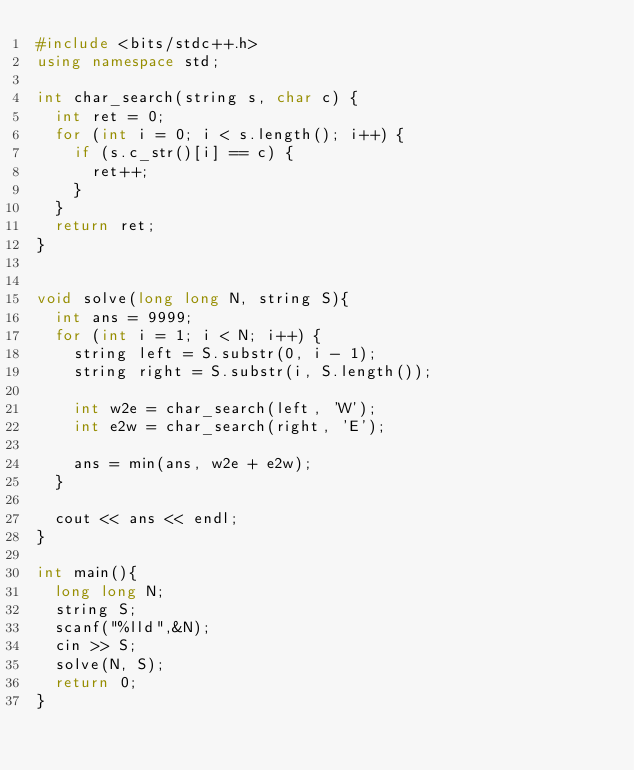<code> <loc_0><loc_0><loc_500><loc_500><_C++_>#include <bits/stdc++.h>
using namespace std;

int char_search(string s, char c) {
	int ret = 0;
	for (int i = 0; i < s.length(); i++) {
		if (s.c_str()[i] == c) {
			ret++;
		} 
	}
	return ret;
}


void solve(long long N, string S){
	int ans = 9999;
	for (int i = 1; i < N; i++) {
		string left = S.substr(0, i - 1);
		string right = S.substr(i, S.length());

		int w2e = char_search(left, 'W');
		int e2w = char_search(right, 'E');

		ans = min(ans, w2e + e2w);
	}

	cout << ans << endl;
}

int main(){	
	long long N;
	string S;
	scanf("%lld",&N);
	cin >> S;
	solve(N, S);
	return 0;
}

</code> 